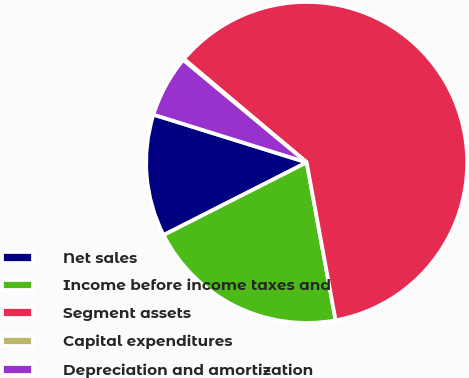Convert chart. <chart><loc_0><loc_0><loc_500><loc_500><pie_chart><fcel>Net sales<fcel>Income before income taxes and<fcel>Segment assets<fcel>Capital expenditures<fcel>Depreciation and amortization<nl><fcel>12.29%<fcel>20.41%<fcel>60.97%<fcel>0.12%<fcel>6.21%<nl></chart> 